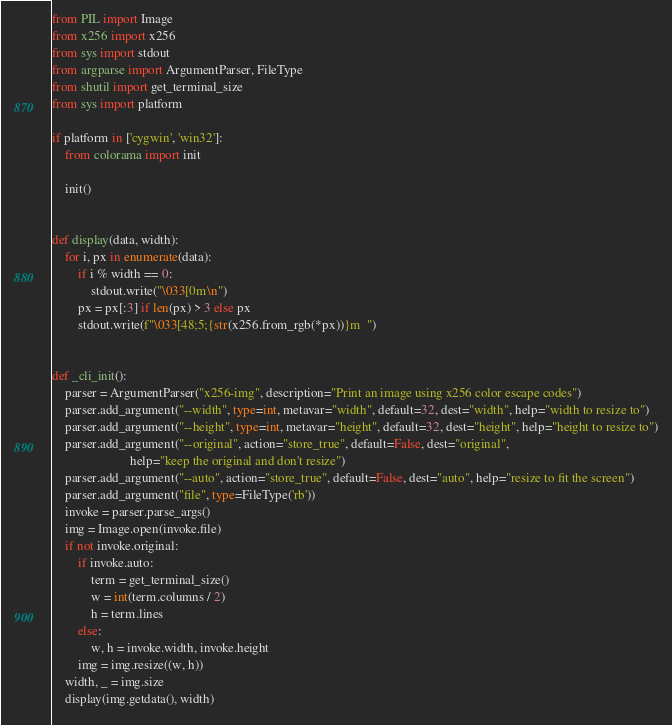<code> <loc_0><loc_0><loc_500><loc_500><_Python_>from PIL import Image
from x256 import x256
from sys import stdout
from argparse import ArgumentParser, FileType
from shutil import get_terminal_size
from sys import platform

if platform in ['cygwin', 'win32']:
    from colorama import init

    init()


def display(data, width):
    for i, px in enumerate(data):
        if i % width == 0:
            stdout.write("\033[0m\n")
        px = px[:3] if len(px) > 3 else px
        stdout.write(f"\033[48;5;{str(x256.from_rgb(*px))}m  ")


def _cli_init():
    parser = ArgumentParser("x256-img", description="Print an image using x256 color escape codes")
    parser.add_argument("--width", type=int, metavar="width", default=32, dest="width", help="width to resize to")
    parser.add_argument("--height", type=int, metavar="height", default=32, dest="height", help="height to resize to")
    parser.add_argument("--original", action="store_true", default=False, dest="original",
                        help="keep the original and don't resize")
    parser.add_argument("--auto", action="store_true", default=False, dest="auto", help="resize to fit the screen")
    parser.add_argument("file", type=FileType('rb'))
    invoke = parser.parse_args()
    img = Image.open(invoke.file)
    if not invoke.original:
        if invoke.auto:
            term = get_terminal_size()
            w = int(term.columns / 2)
            h = term.lines
        else:
            w, h = invoke.width, invoke.height
        img = img.resize((w, h))
    width, _ = img.size
    display(img.getdata(), width)
</code> 